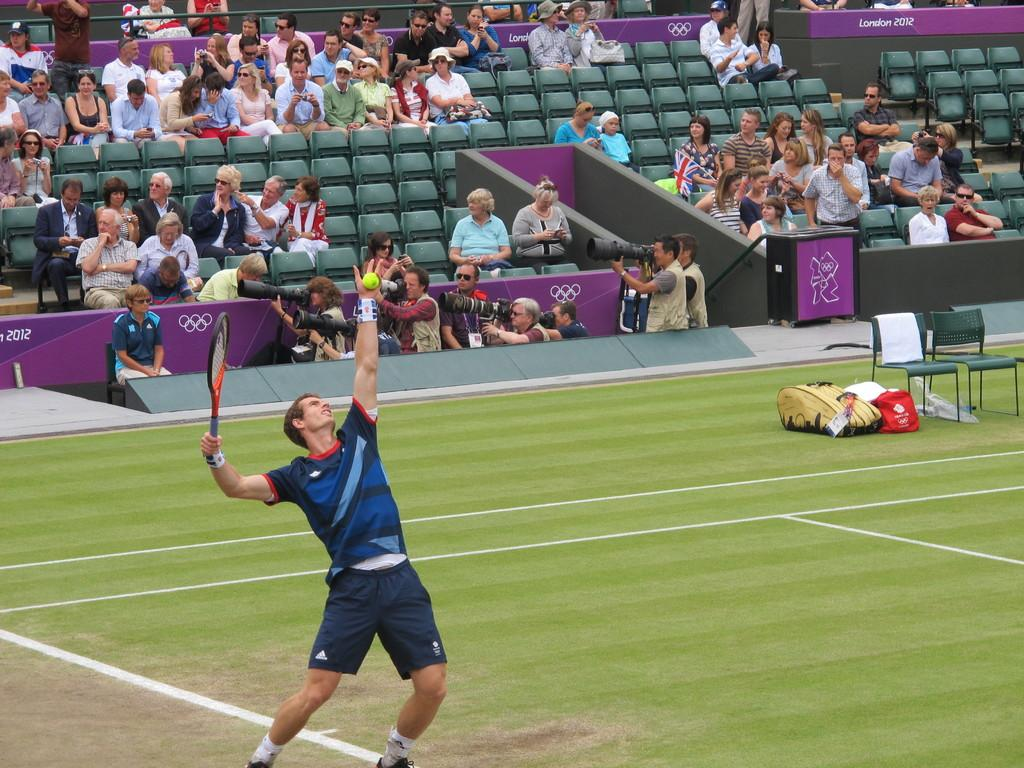<image>
Create a compact narrative representing the image presented. Man about to serve a tennis ball while wearing Adidas shorts. 